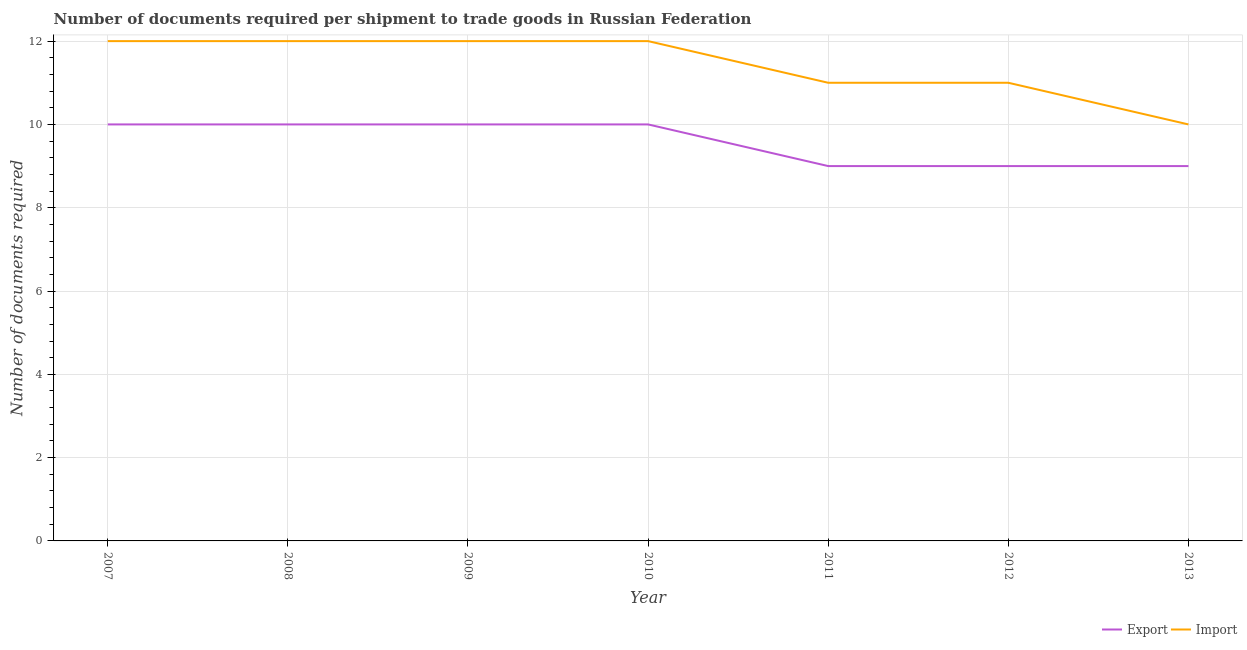How many different coloured lines are there?
Keep it short and to the point. 2. What is the number of documents required to export goods in 2013?
Give a very brief answer. 9. Across all years, what is the maximum number of documents required to import goods?
Provide a succinct answer. 12. Across all years, what is the minimum number of documents required to import goods?
Provide a succinct answer. 10. In which year was the number of documents required to export goods maximum?
Ensure brevity in your answer.  2007. What is the total number of documents required to import goods in the graph?
Provide a succinct answer. 80. What is the difference between the number of documents required to export goods in 2009 and that in 2010?
Provide a succinct answer. 0. What is the difference between the number of documents required to export goods in 2008 and the number of documents required to import goods in 2009?
Ensure brevity in your answer.  -2. What is the average number of documents required to import goods per year?
Provide a short and direct response. 11.43. In the year 2012, what is the difference between the number of documents required to import goods and number of documents required to export goods?
Give a very brief answer. 2. What is the difference between the highest and the second highest number of documents required to import goods?
Offer a very short reply. 0. What is the difference between the highest and the lowest number of documents required to export goods?
Make the answer very short. 1. Is the number of documents required to export goods strictly greater than the number of documents required to import goods over the years?
Your answer should be very brief. No. Is the number of documents required to export goods strictly less than the number of documents required to import goods over the years?
Provide a succinct answer. Yes. How many years are there in the graph?
Provide a short and direct response. 7. What is the difference between two consecutive major ticks on the Y-axis?
Offer a very short reply. 2. Are the values on the major ticks of Y-axis written in scientific E-notation?
Your answer should be very brief. No. Does the graph contain any zero values?
Your answer should be very brief. No. Does the graph contain grids?
Provide a succinct answer. Yes. Where does the legend appear in the graph?
Your response must be concise. Bottom right. How are the legend labels stacked?
Your answer should be compact. Horizontal. What is the title of the graph?
Provide a succinct answer. Number of documents required per shipment to trade goods in Russian Federation. What is the label or title of the Y-axis?
Ensure brevity in your answer.  Number of documents required. What is the Number of documents required of Export in 2008?
Your response must be concise. 10. What is the Number of documents required of Import in 2008?
Your answer should be very brief. 12. What is the Number of documents required of Export in 2009?
Your answer should be very brief. 10. What is the Number of documents required in Import in 2009?
Ensure brevity in your answer.  12. What is the Number of documents required of Import in 2010?
Make the answer very short. 12. What is the Number of documents required of Import in 2011?
Provide a succinct answer. 11. What is the Number of documents required of Export in 2013?
Provide a succinct answer. 9. What is the Number of documents required of Import in 2013?
Provide a short and direct response. 10. Across all years, what is the maximum Number of documents required of Import?
Give a very brief answer. 12. Across all years, what is the minimum Number of documents required in Export?
Give a very brief answer. 9. Across all years, what is the minimum Number of documents required of Import?
Your response must be concise. 10. What is the total Number of documents required of Import in the graph?
Keep it short and to the point. 80. What is the difference between the Number of documents required in Export in 2007 and that in 2008?
Give a very brief answer. 0. What is the difference between the Number of documents required in Export in 2007 and that in 2011?
Provide a short and direct response. 1. What is the difference between the Number of documents required in Import in 2007 and that in 2011?
Your response must be concise. 1. What is the difference between the Number of documents required in Import in 2008 and that in 2009?
Make the answer very short. 0. What is the difference between the Number of documents required of Import in 2008 and that in 2010?
Your answer should be very brief. 0. What is the difference between the Number of documents required in Import in 2008 and that in 2013?
Provide a short and direct response. 2. What is the difference between the Number of documents required in Import in 2009 and that in 2010?
Keep it short and to the point. 0. What is the difference between the Number of documents required of Import in 2009 and that in 2012?
Your answer should be very brief. 1. What is the difference between the Number of documents required of Export in 2009 and that in 2013?
Provide a succinct answer. 1. What is the difference between the Number of documents required of Export in 2010 and that in 2012?
Offer a terse response. 1. What is the difference between the Number of documents required in Import in 2010 and that in 2012?
Give a very brief answer. 1. What is the difference between the Number of documents required in Export in 2010 and that in 2013?
Ensure brevity in your answer.  1. What is the difference between the Number of documents required of Import in 2011 and that in 2012?
Your answer should be compact. 0. What is the difference between the Number of documents required in Export in 2011 and that in 2013?
Provide a short and direct response. 0. What is the difference between the Number of documents required of Import in 2011 and that in 2013?
Offer a very short reply. 1. What is the difference between the Number of documents required in Export in 2007 and the Number of documents required in Import in 2009?
Ensure brevity in your answer.  -2. What is the difference between the Number of documents required of Export in 2007 and the Number of documents required of Import in 2012?
Give a very brief answer. -1. What is the difference between the Number of documents required in Export in 2007 and the Number of documents required in Import in 2013?
Provide a succinct answer. 0. What is the difference between the Number of documents required of Export in 2008 and the Number of documents required of Import in 2011?
Ensure brevity in your answer.  -1. What is the difference between the Number of documents required of Export in 2008 and the Number of documents required of Import in 2012?
Your answer should be compact. -1. What is the difference between the Number of documents required in Export in 2009 and the Number of documents required in Import in 2011?
Keep it short and to the point. -1. What is the difference between the Number of documents required in Export in 2009 and the Number of documents required in Import in 2012?
Keep it short and to the point. -1. What is the difference between the Number of documents required of Export in 2010 and the Number of documents required of Import in 2011?
Offer a very short reply. -1. What is the difference between the Number of documents required of Export in 2010 and the Number of documents required of Import in 2012?
Your answer should be very brief. -1. What is the difference between the Number of documents required in Export in 2011 and the Number of documents required in Import in 2012?
Keep it short and to the point. -2. What is the average Number of documents required in Export per year?
Offer a terse response. 9.57. What is the average Number of documents required in Import per year?
Ensure brevity in your answer.  11.43. In the year 2009, what is the difference between the Number of documents required of Export and Number of documents required of Import?
Your answer should be very brief. -2. In the year 2010, what is the difference between the Number of documents required of Export and Number of documents required of Import?
Provide a short and direct response. -2. In the year 2012, what is the difference between the Number of documents required of Export and Number of documents required of Import?
Your answer should be very brief. -2. In the year 2013, what is the difference between the Number of documents required in Export and Number of documents required in Import?
Offer a terse response. -1. What is the ratio of the Number of documents required in Import in 2007 to that in 2008?
Your answer should be compact. 1. What is the ratio of the Number of documents required of Export in 2007 to that in 2009?
Make the answer very short. 1. What is the ratio of the Number of documents required of Import in 2007 to that in 2009?
Provide a short and direct response. 1. What is the ratio of the Number of documents required in Export in 2007 to that in 2010?
Provide a short and direct response. 1. What is the ratio of the Number of documents required of Import in 2007 to that in 2010?
Give a very brief answer. 1. What is the ratio of the Number of documents required of Export in 2007 to that in 2012?
Offer a very short reply. 1.11. What is the ratio of the Number of documents required of Export in 2007 to that in 2013?
Give a very brief answer. 1.11. What is the ratio of the Number of documents required in Import in 2007 to that in 2013?
Ensure brevity in your answer.  1.2. What is the ratio of the Number of documents required in Export in 2008 to that in 2009?
Your answer should be compact. 1. What is the ratio of the Number of documents required of Export in 2008 to that in 2010?
Give a very brief answer. 1. What is the ratio of the Number of documents required in Import in 2008 to that in 2010?
Your response must be concise. 1. What is the ratio of the Number of documents required in Import in 2008 to that in 2011?
Give a very brief answer. 1.09. What is the ratio of the Number of documents required in Export in 2008 to that in 2012?
Offer a very short reply. 1.11. What is the ratio of the Number of documents required of Import in 2008 to that in 2012?
Offer a terse response. 1.09. What is the ratio of the Number of documents required in Export in 2008 to that in 2013?
Provide a succinct answer. 1.11. What is the ratio of the Number of documents required of Export in 2009 to that in 2010?
Provide a short and direct response. 1. What is the ratio of the Number of documents required in Export in 2009 to that in 2012?
Keep it short and to the point. 1.11. What is the ratio of the Number of documents required in Import in 2009 to that in 2012?
Your response must be concise. 1.09. What is the ratio of the Number of documents required of Import in 2009 to that in 2013?
Make the answer very short. 1.2. What is the ratio of the Number of documents required in Export in 2010 to that in 2011?
Ensure brevity in your answer.  1.11. What is the ratio of the Number of documents required of Export in 2010 to that in 2012?
Make the answer very short. 1.11. What is the ratio of the Number of documents required in Import in 2010 to that in 2013?
Your answer should be very brief. 1.2. What is the ratio of the Number of documents required of Export in 2011 to that in 2012?
Make the answer very short. 1. What is the ratio of the Number of documents required in Export in 2011 to that in 2013?
Offer a very short reply. 1. What is the ratio of the Number of documents required in Export in 2012 to that in 2013?
Keep it short and to the point. 1. What is the ratio of the Number of documents required of Import in 2012 to that in 2013?
Provide a succinct answer. 1.1. What is the difference between the highest and the second highest Number of documents required of Import?
Ensure brevity in your answer.  0. What is the difference between the highest and the lowest Number of documents required of Import?
Provide a short and direct response. 2. 